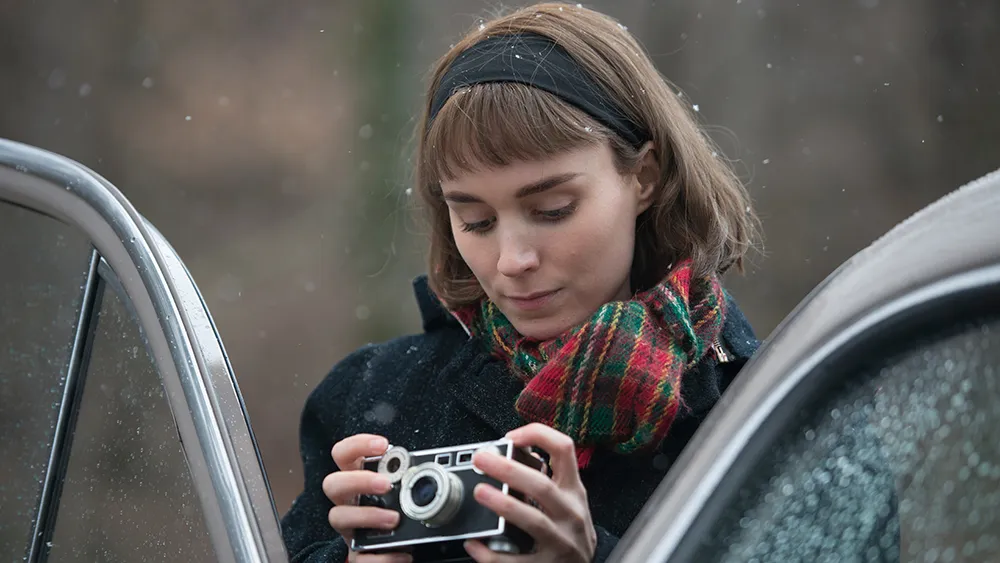Describe the following image. In this serene and captivating image, we see a woman deeply absorbed in a moment of reflection. She is dressed in a sophisticated black coat and complemented by a vibrant red and green plaid scarf that adds a splash of color to her outfit. Her hair, styled in a neat short bob and held back by a black headband, frames her face as she focuses intently on the vintage camera she holds in her hands. The background blurs into a blend of earth tones and delicate snowflakes, suggesting a tranquil woodland backdrop. The car next to her, dotted with rain droplets, evokes a sense of calm and introspective beauty, perhaps indicating a pause during a peaceful journey or a contemplative moment amid a busy day. 